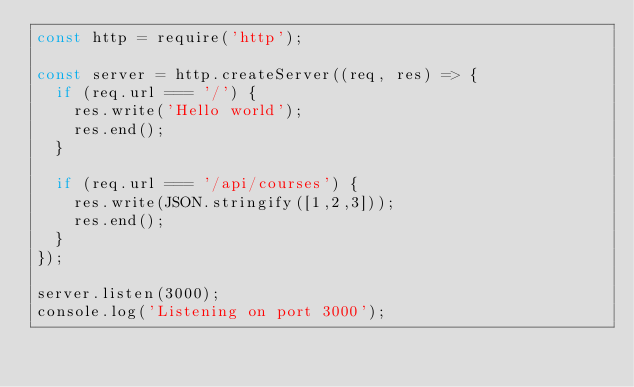<code> <loc_0><loc_0><loc_500><loc_500><_JavaScript_>const http = require('http');

const server = http.createServer((req, res) => {
	if (req.url === '/') {
		res.write('Hello world');
		res.end();
	}

	if (req.url === '/api/courses') {
		res.write(JSON.stringify([1,2,3]));
		res.end();
	}
});

server.listen(3000);
console.log('Listening on port 3000');</code> 